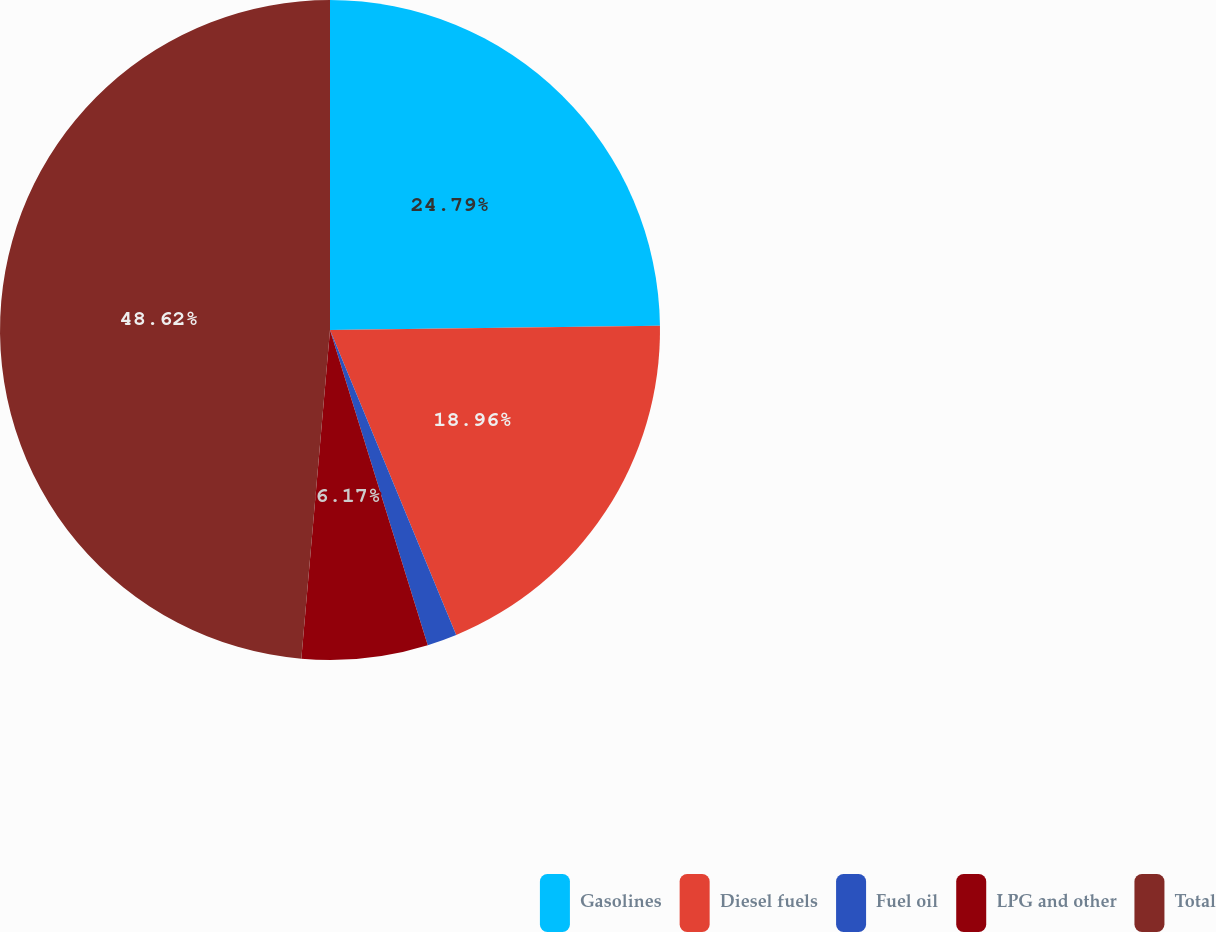<chart> <loc_0><loc_0><loc_500><loc_500><pie_chart><fcel>Gasolines<fcel>Diesel fuels<fcel>Fuel oil<fcel>LPG and other<fcel>Total<nl><fcel>24.79%<fcel>18.96%<fcel>1.46%<fcel>6.17%<fcel>48.61%<nl></chart> 